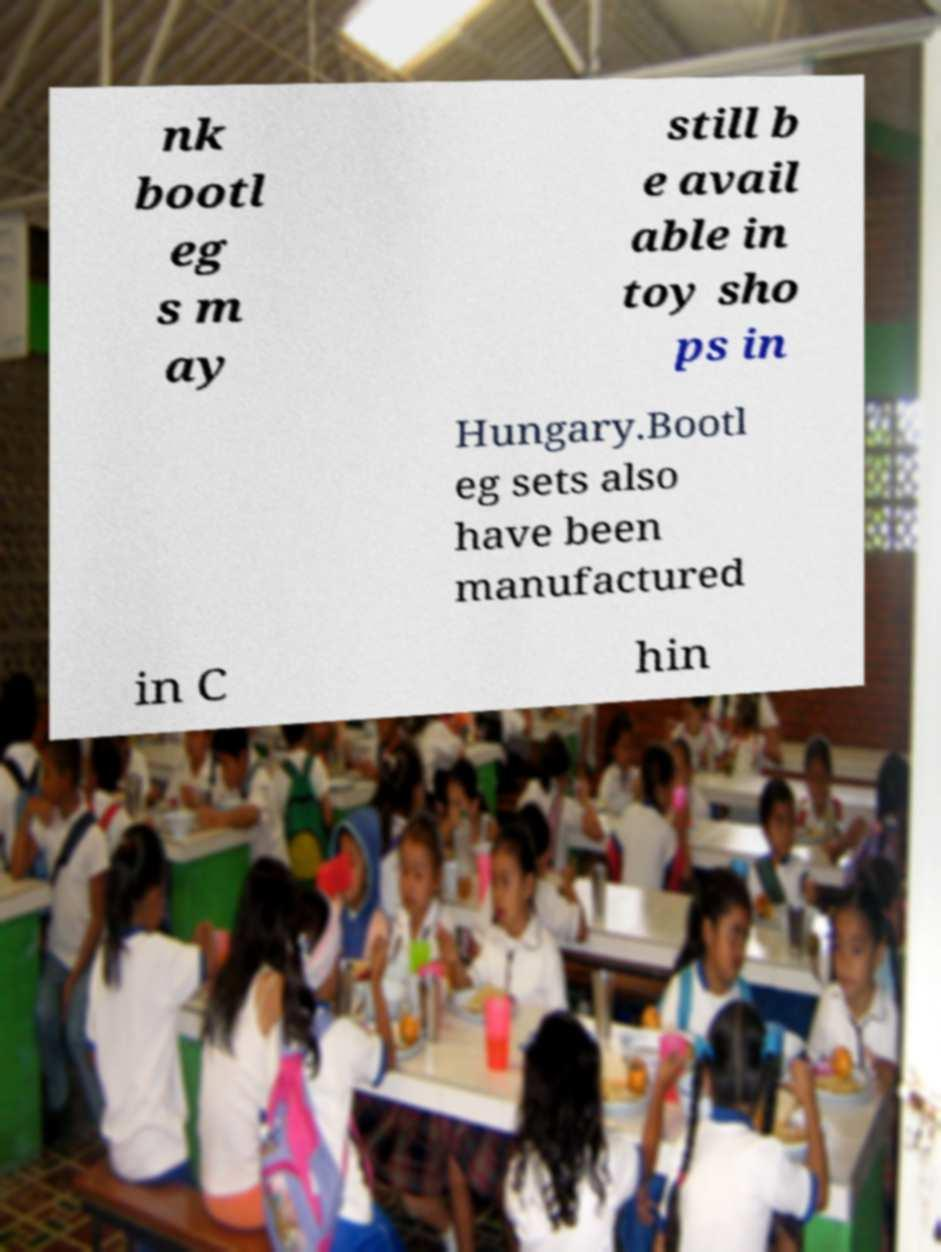There's text embedded in this image that I need extracted. Can you transcribe it verbatim? nk bootl eg s m ay still b e avail able in toy sho ps in Hungary.Bootl eg sets also have been manufactured in C hin 